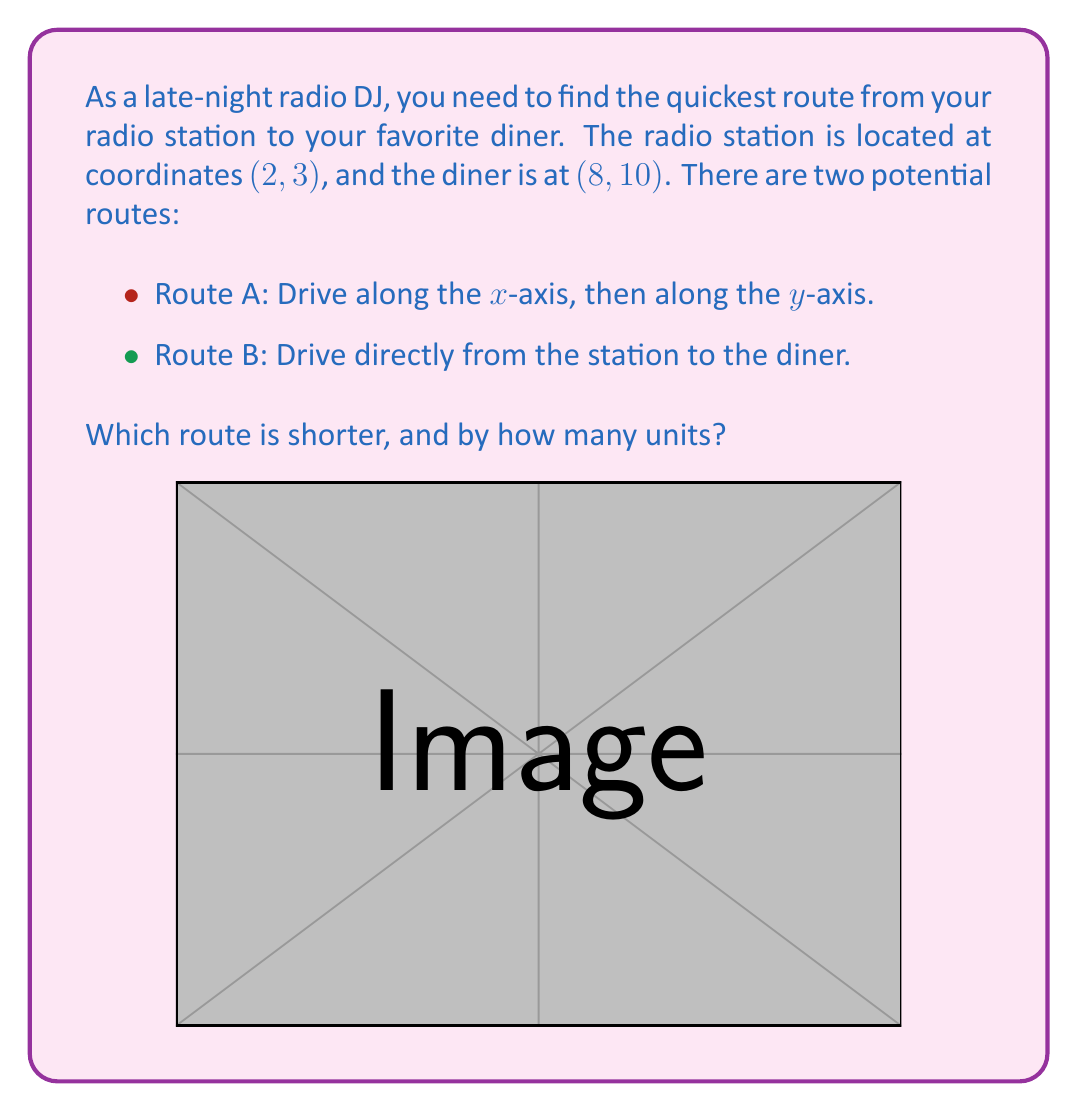Show me your answer to this math problem. To solve this problem, we need to calculate the distances for both routes and compare them.

Route A (driving along axes):
1. Distance along x-axis: $8 - 2 = 6$ units
2. Distance along y-axis: $10 - 3 = 7$ units
3. Total distance for Route A: $6 + 7 = 13$ units

Route B (direct route):
We can use the distance formula to calculate this:
$$d = \sqrt{(x_2-x_1)^2 + (y_2-y_1)^2}$$

Where $(x_1,y_1)$ is (2,3) and $(x_2,y_2)$ is (8,10).

$$\begin{align}
d &= \sqrt{(8-2)^2 + (10-3)^2} \\
&= \sqrt{6^2 + 7^2} \\
&= \sqrt{36 + 49} \\
&= \sqrt{85} \\
&\approx 9.22 \text{ units}
\end{align}$$

Comparing the two routes:
Route A: 13 units
Route B: $\sqrt{85} \approx 9.22$ units

Route B (the direct route) is shorter.

The difference in distance is:
$$13 - \sqrt{85} \approx 13 - 9.22 = 3.78 \text{ units}$$
Answer: Route B (the direct route) is shorter by approximately 3.78 units. 